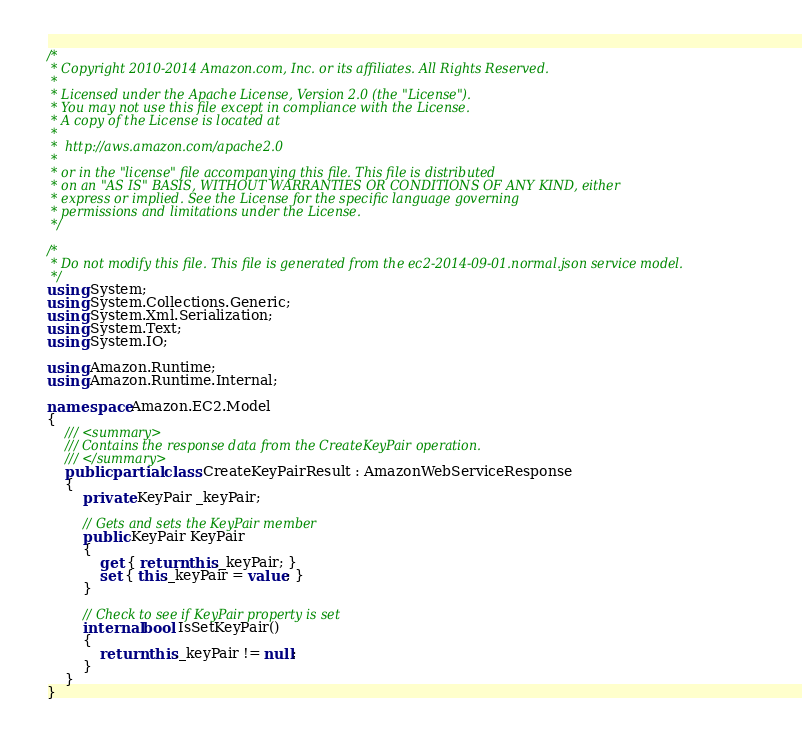Convert code to text. <code><loc_0><loc_0><loc_500><loc_500><_C#_>/*
 * Copyright 2010-2014 Amazon.com, Inc. or its affiliates. All Rights Reserved.
 * 
 * Licensed under the Apache License, Version 2.0 (the "License").
 * You may not use this file except in compliance with the License.
 * A copy of the License is located at
 * 
 *  http://aws.amazon.com/apache2.0
 * 
 * or in the "license" file accompanying this file. This file is distributed
 * on an "AS IS" BASIS, WITHOUT WARRANTIES OR CONDITIONS OF ANY KIND, either
 * express or implied. See the License for the specific language governing
 * permissions and limitations under the License.
 */

/*
 * Do not modify this file. This file is generated from the ec2-2014-09-01.normal.json service model.
 */
using System;
using System.Collections.Generic;
using System.Xml.Serialization;
using System.Text;
using System.IO;

using Amazon.Runtime;
using Amazon.Runtime.Internal;

namespace Amazon.EC2.Model
{
    /// <summary>
    /// Contains the response data from the CreateKeyPair operation.
    /// </summary>
    public partial class CreateKeyPairResult : AmazonWebServiceResponse
    {
        private KeyPair _keyPair;

        // Gets and sets the KeyPair member
        public KeyPair KeyPair
        {
            get { return this._keyPair; }
            set { this._keyPair = value; }
        }

        // Check to see if KeyPair property is set
        internal bool IsSetKeyPair()
        {
            return this._keyPair != null;
        }
    }
}</code> 